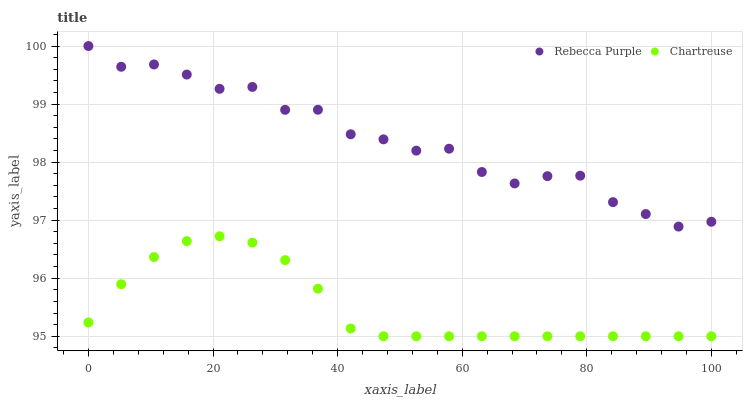Does Chartreuse have the minimum area under the curve?
Answer yes or no. Yes. Does Rebecca Purple have the maximum area under the curve?
Answer yes or no. Yes. Does Rebecca Purple have the minimum area under the curve?
Answer yes or no. No. Is Chartreuse the smoothest?
Answer yes or no. Yes. Is Rebecca Purple the roughest?
Answer yes or no. Yes. Is Rebecca Purple the smoothest?
Answer yes or no. No. Does Chartreuse have the lowest value?
Answer yes or no. Yes. Does Rebecca Purple have the lowest value?
Answer yes or no. No. Does Rebecca Purple have the highest value?
Answer yes or no. Yes. Is Chartreuse less than Rebecca Purple?
Answer yes or no. Yes. Is Rebecca Purple greater than Chartreuse?
Answer yes or no. Yes. Does Chartreuse intersect Rebecca Purple?
Answer yes or no. No. 